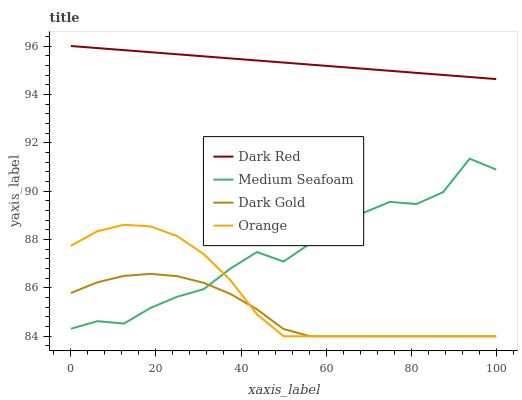Does Dark Gold have the minimum area under the curve?
Answer yes or no. Yes. Does Dark Red have the maximum area under the curve?
Answer yes or no. Yes. Does Medium Seafoam have the minimum area under the curve?
Answer yes or no. No. Does Medium Seafoam have the maximum area under the curve?
Answer yes or no. No. Is Dark Red the smoothest?
Answer yes or no. Yes. Is Medium Seafoam the roughest?
Answer yes or no. Yes. Is Medium Seafoam the smoothest?
Answer yes or no. No. Is Dark Red the roughest?
Answer yes or no. No. Does Orange have the lowest value?
Answer yes or no. Yes. Does Medium Seafoam have the lowest value?
Answer yes or no. No. Does Dark Red have the highest value?
Answer yes or no. Yes. Does Medium Seafoam have the highest value?
Answer yes or no. No. Is Orange less than Dark Red?
Answer yes or no. Yes. Is Dark Red greater than Dark Gold?
Answer yes or no. Yes. Does Orange intersect Dark Gold?
Answer yes or no. Yes. Is Orange less than Dark Gold?
Answer yes or no. No. Is Orange greater than Dark Gold?
Answer yes or no. No. Does Orange intersect Dark Red?
Answer yes or no. No. 